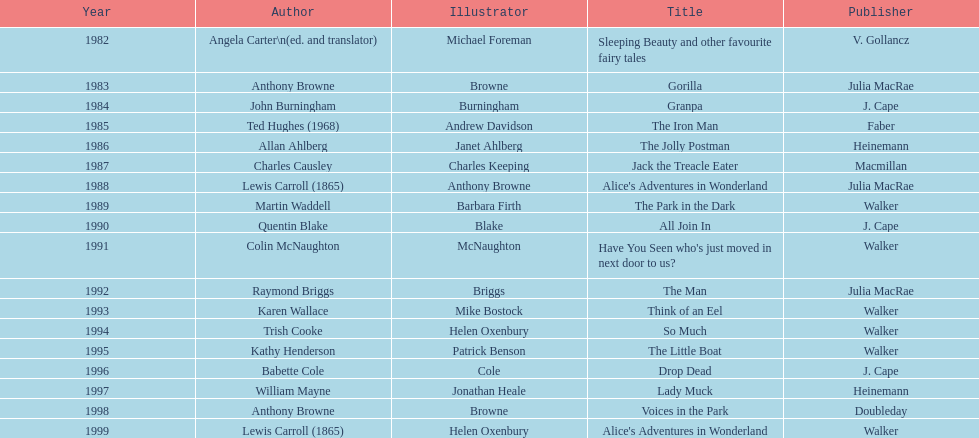How many titles had the author also credited as the illustrator? 7. 